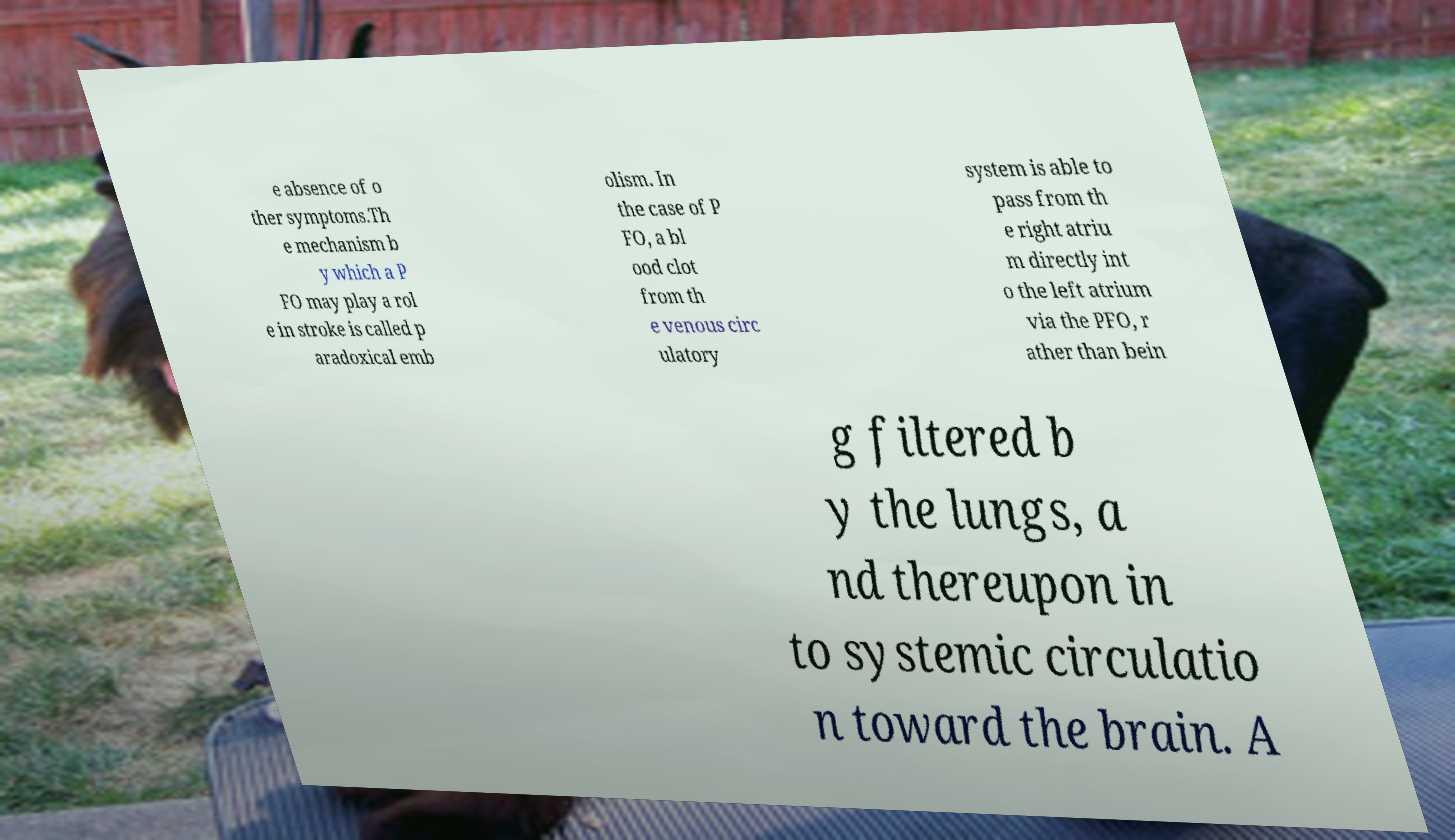Could you assist in decoding the text presented in this image and type it out clearly? e absence of o ther symptoms.Th e mechanism b y which a P FO may play a rol e in stroke is called p aradoxical emb olism. In the case of P FO, a bl ood clot from th e venous circ ulatory system is able to pass from th e right atriu m directly int o the left atrium via the PFO, r ather than bein g filtered b y the lungs, a nd thereupon in to systemic circulatio n toward the brain. A 